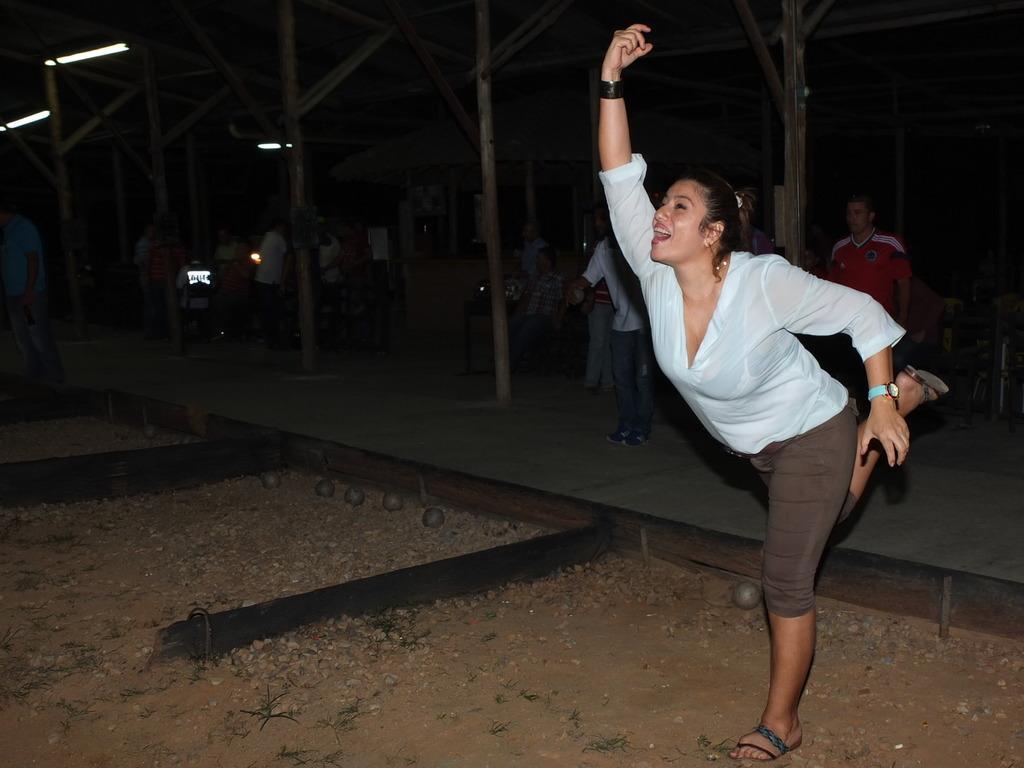Please provide a concise description of this image. In this image I can see on the right side there is a woman raising her hand, she is wearing shirt, trouser. In the background few people are there. In the top left hand side there are lights. 